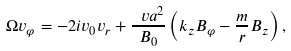Convert formula to latex. <formula><loc_0><loc_0><loc_500><loc_500>\Omega v _ { \varphi } = - 2 i v _ { 0 } v _ { r } + \frac { \ v a ^ { 2 } } { B _ { 0 } } \left ( k _ { z } B _ { \varphi } - \frac { m } { r } B _ { z } \right ) ,</formula> 